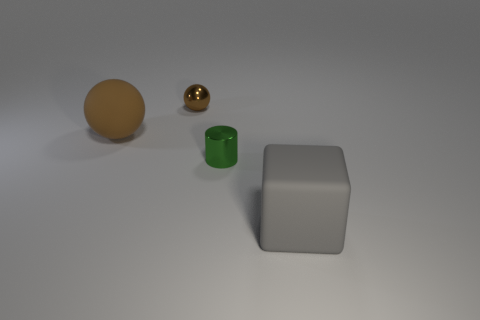Add 3 large blue metal spheres. How many objects exist? 7 Subtract all cylinders. How many objects are left? 3 Add 3 tiny green cylinders. How many tiny green cylinders are left? 4 Add 2 small purple cylinders. How many small purple cylinders exist? 2 Subtract 0 cyan cylinders. How many objects are left? 4 Subtract all small metallic spheres. Subtract all green cylinders. How many objects are left? 2 